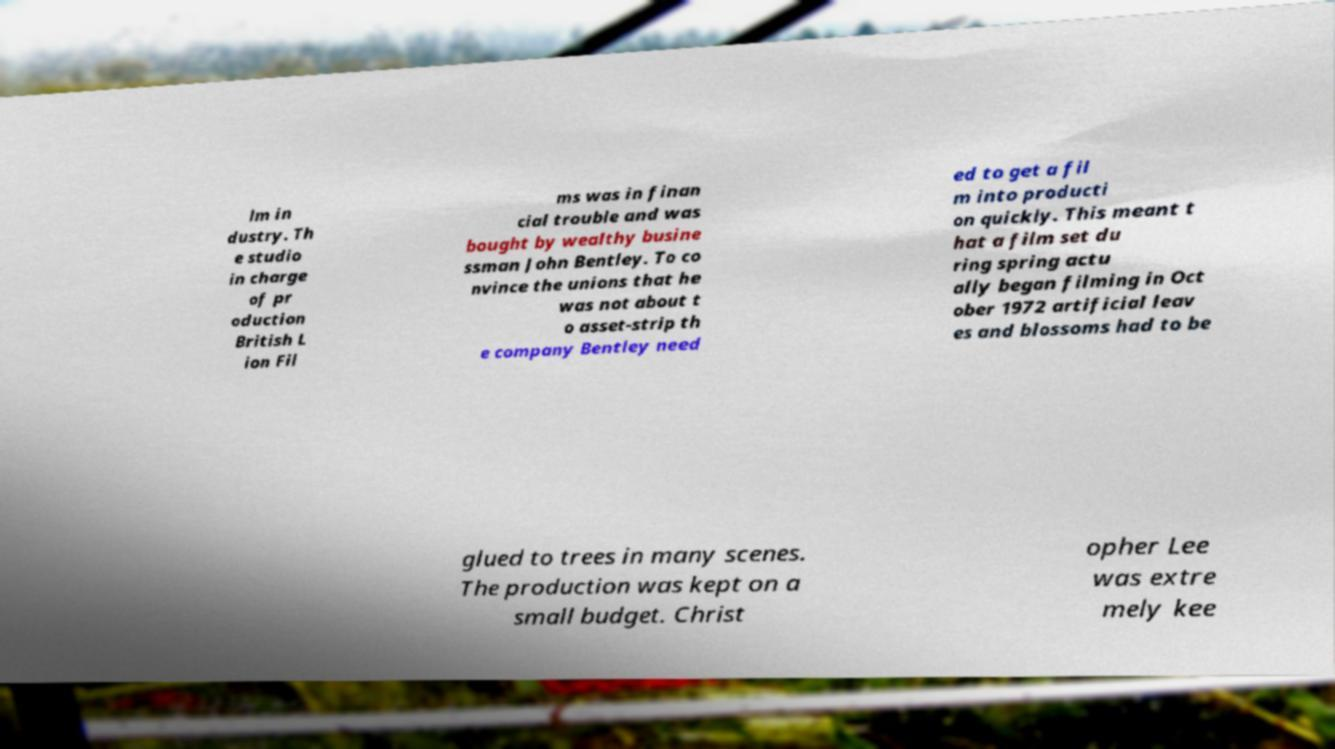Can you read and provide the text displayed in the image?This photo seems to have some interesting text. Can you extract and type it out for me? lm in dustry. Th e studio in charge of pr oduction British L ion Fil ms was in finan cial trouble and was bought by wealthy busine ssman John Bentley. To co nvince the unions that he was not about t o asset-strip th e company Bentley need ed to get a fil m into producti on quickly. This meant t hat a film set du ring spring actu ally began filming in Oct ober 1972 artificial leav es and blossoms had to be glued to trees in many scenes. The production was kept on a small budget. Christ opher Lee was extre mely kee 